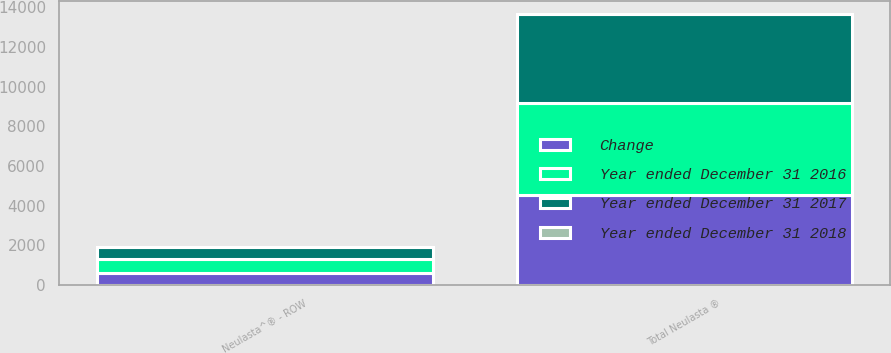Convert chart. <chart><loc_0><loc_0><loc_500><loc_500><stacked_bar_chart><ecel><fcel>Neulasta^® - ROW<fcel>Total Neulasta ®<nl><fcel>Year ended December 31 2017<fcel>609<fcel>4475<nl><fcel>Year ended December 31 2018<fcel>1<fcel>1<nl><fcel>Change<fcel>603<fcel>4534<nl><fcel>Year ended December 31 2016<fcel>723<fcel>4648<nl></chart> 